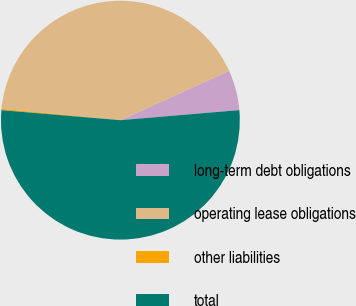Convert chart. <chart><loc_0><loc_0><loc_500><loc_500><pie_chart><fcel>long-term debt obligations<fcel>operating lease obligations<fcel>other liabilities<fcel>total<nl><fcel>5.43%<fcel>41.71%<fcel>0.18%<fcel>52.68%<nl></chart> 